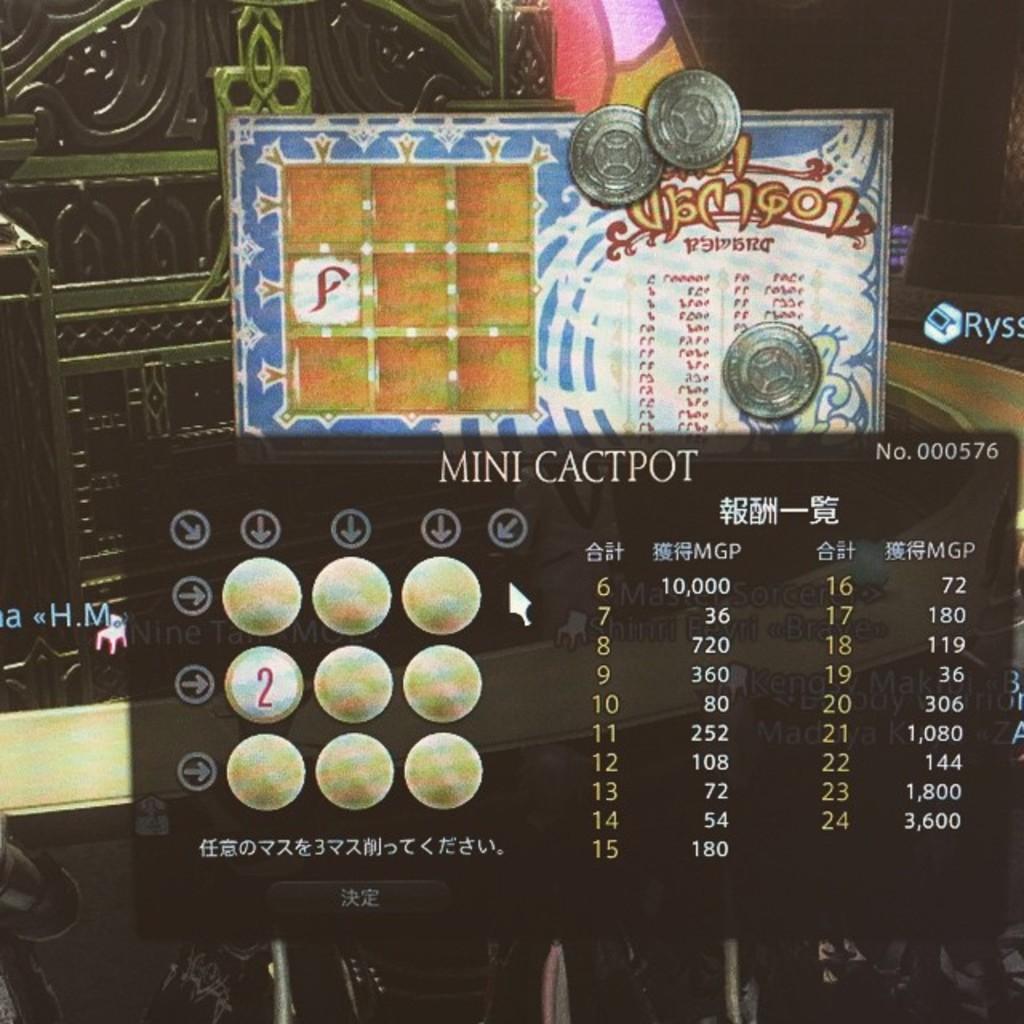What is the no. on the top right?
Offer a very short reply. 000576. Minicactpot it s a game?
Offer a terse response. Yes. 